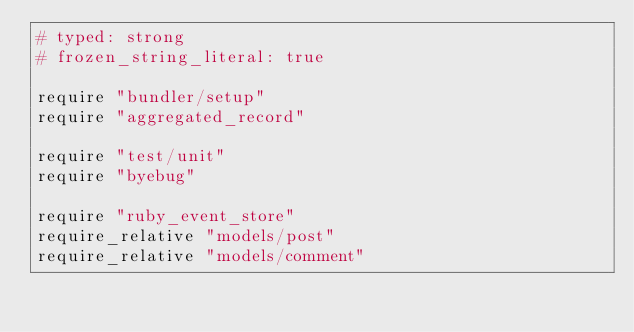Convert code to text. <code><loc_0><loc_0><loc_500><loc_500><_Ruby_># typed: strong
# frozen_string_literal: true

require "bundler/setup"
require "aggregated_record"

require "test/unit"
require "byebug"

require "ruby_event_store"
require_relative "models/post"
require_relative "models/comment"
</code> 